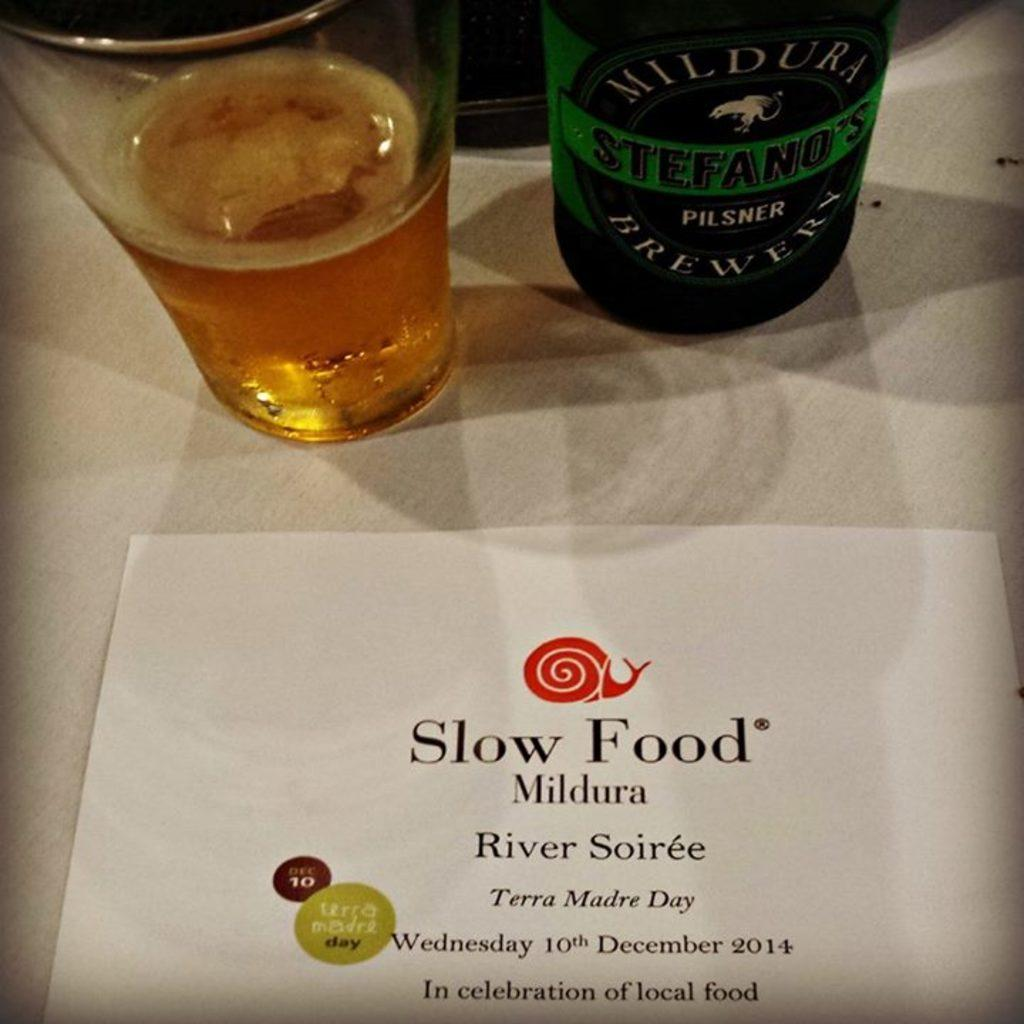<image>
Create a compact narrative representing the image presented. A sign near a bottle and glass of beer says "Slow Food" on it and has a little picture of a snail. 